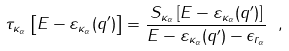<formula> <loc_0><loc_0><loc_500><loc_500>\tau _ { \kappa _ { \alpha } } \left [ E - \varepsilon _ { \kappa _ { \alpha } } ( q ^ { \prime } ) \right ] = \frac { S _ { \kappa _ { \alpha } } \left [ E - \varepsilon _ { \kappa _ { \alpha } } ( q ^ { \prime } ) \right ] } { E - \varepsilon _ { \kappa _ { \alpha } } ( q ^ { \prime } ) - \epsilon _ { r _ { \alpha } } } \ ,</formula> 